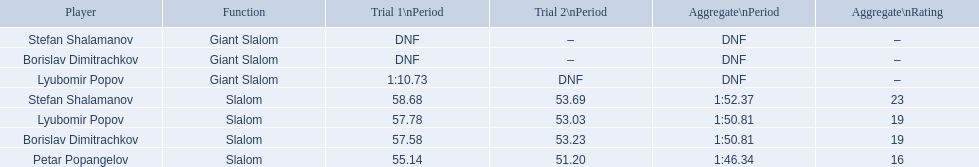What are all the competitions lyubomir popov competed in? Lyubomir Popov, Lyubomir Popov. Of those, which were giant slalom races? Giant Slalom. Could you parse the entire table as a dict? {'header': ['Player', 'Function', 'Trial 1\\nPeriod', 'Trial 2\\nPeriod', 'Aggregate\\nPeriod', 'Aggregate\\nRating'], 'rows': [['Stefan Shalamanov', 'Giant Slalom', 'DNF', '–', 'DNF', '–'], ['Borislav Dimitrachkov', 'Giant Slalom', 'DNF', '–', 'DNF', '–'], ['Lyubomir Popov', 'Giant Slalom', '1:10.73', 'DNF', 'DNF', '–'], ['Stefan Shalamanov', 'Slalom', '58.68', '53.69', '1:52.37', '23'], ['Lyubomir Popov', 'Slalom', '57.78', '53.03', '1:50.81', '19'], ['Borislav Dimitrachkov', 'Slalom', '57.58', '53.23', '1:50.81', '19'], ['Petar Popangelov', 'Slalom', '55.14', '51.20', '1:46.34', '16']]} What was his time in race 1? 1:10.73. 